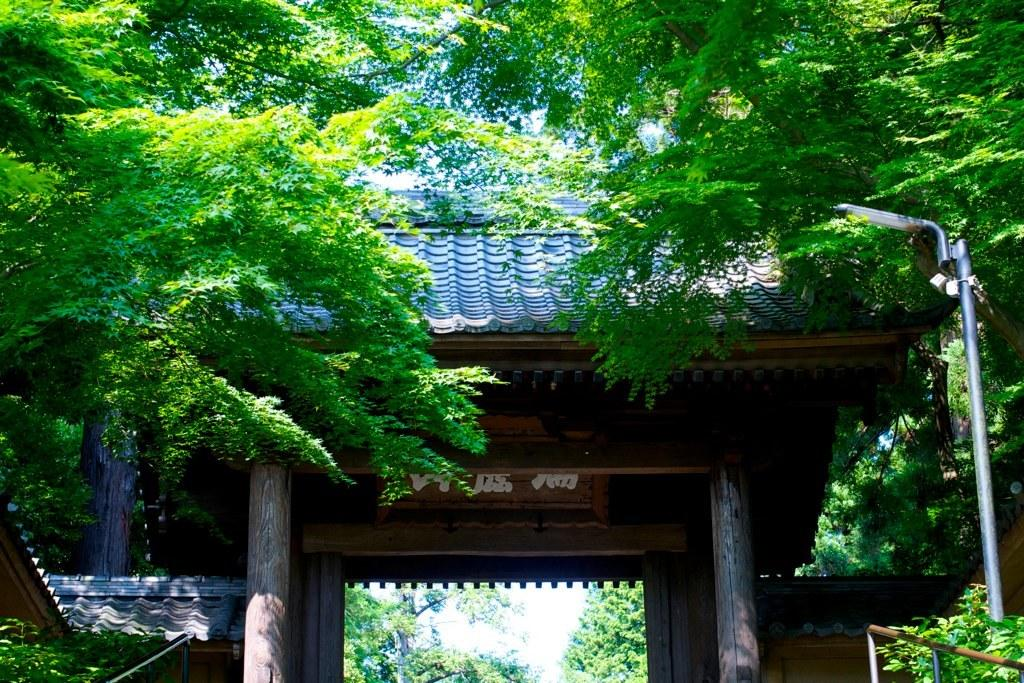What type of structure is in the image? There is a wooden shelter in the image. What is written or displayed on a board in the image? There is a board with text in the image. Where is the light pole located in the image? The light pole is on the right side of the image. What type of natural elements can be seen in the image? Trees are visible at the top of the image. What type of throat treatment is being offered in the image? There is no throat treatment or any reference to a throat in the image. 